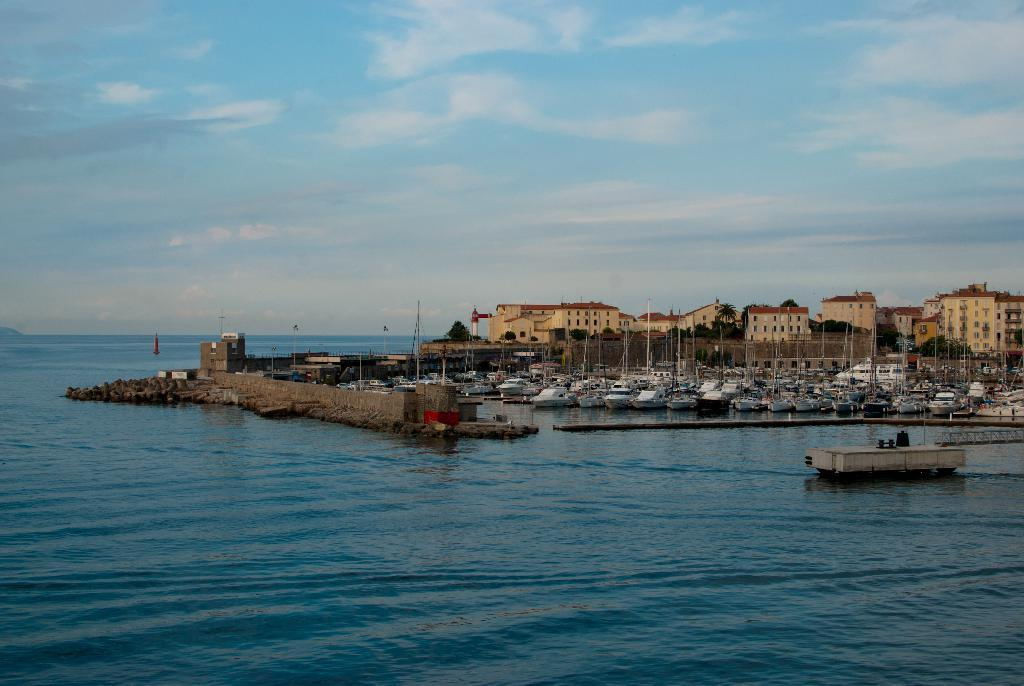What is the main subject of the image? The main subject of the image is many boats on water in the center. What structures can be seen in the image? There is a wall and poles visible in the image. What can be seen in the background of the image? In the background, there are clouds, buildings, another wall, windows, a roof, trees, and water visible. What type of apparatus is being used by the boats in the image? There is no apparatus visible in the image; the boats are simply on the water. What kind of art can be seen on the boats in the image? There is no art visible on the boats in the image. 